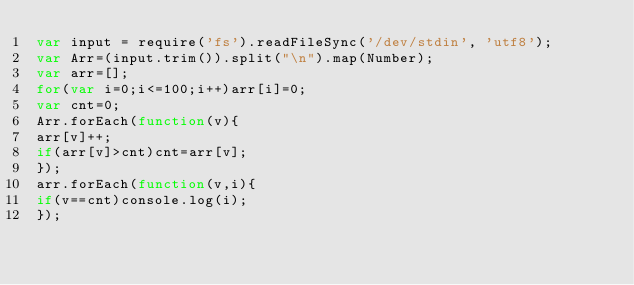Convert code to text. <code><loc_0><loc_0><loc_500><loc_500><_JavaScript_>var input = require('fs').readFileSync('/dev/stdin', 'utf8');
var Arr=(input.trim()).split("\n").map(Number);
var arr=[];
for(var i=0;i<=100;i++)arr[i]=0;
var cnt=0;
Arr.forEach(function(v){
arr[v]++;
if(arr[v]>cnt)cnt=arr[v];
});
arr.forEach(function(v,i){
if(v==cnt)console.log(i);
});</code> 